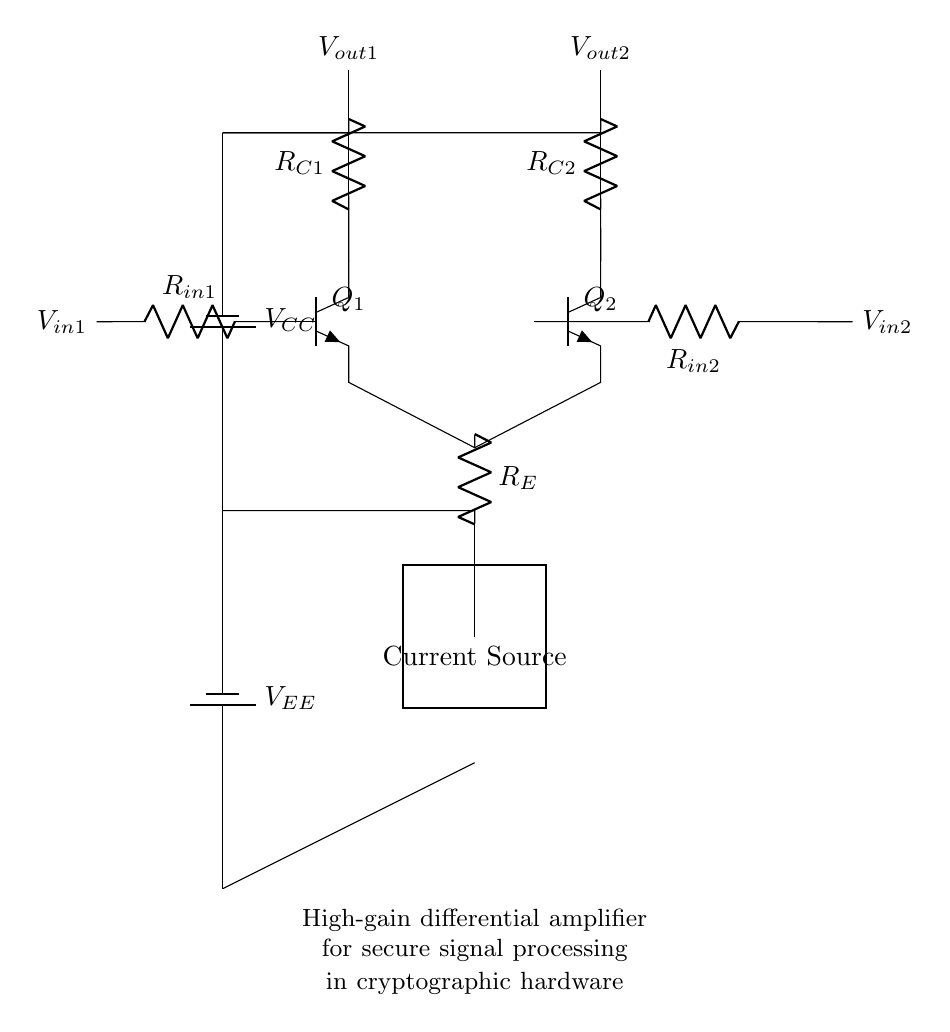What are the input resistors used in the circuit? The input resistors are R_in1 and R_in2, which are connected to the bases of the transistors Q1 and Q2. These resistors are critical for determining the input impedance of the differential amplifier.
Answer: R_in1, R_in2 What is the function of the current source in this circuit? The current source provides a constant biasing current for the emitter resistors, ensuring that the transistors Q1 and Q2 operate in the active region for linear amplification. This configuration is essential for maintaining high gain in differential amplifiers.
Answer: Biasing current Which components determine the output voltage of the transistors? The output voltage of the transistors is determined by the collector resistors R_C1 and R_C2, which convert the current through the transistors into voltage output, influencing the gain of the amplifier.
Answer: R_C1, R_C2 How many transistors are used in the differential amplifier? There are two transistors, Q1 and Q2, which form the differential pair of the amplifier, allowing it to amplify the difference between the input signals applied to their bases.
Answer: Two What configuration does this high-gain differential amplifier utilize? This configuration is a differential pair with separate collectors for each transistor, which allows it to amplify the difference between the two input voltages while rejecting common-mode signals.
Answer: Differential pair What type of power supply is indicated in the circuit? The circuit uses a dual power supply indicated as V_CC and V_EE, providing positive and negative voltages essential for the operation of the differential amplifier. This is important for proper transistor biasing.
Answer: Dual power supply 